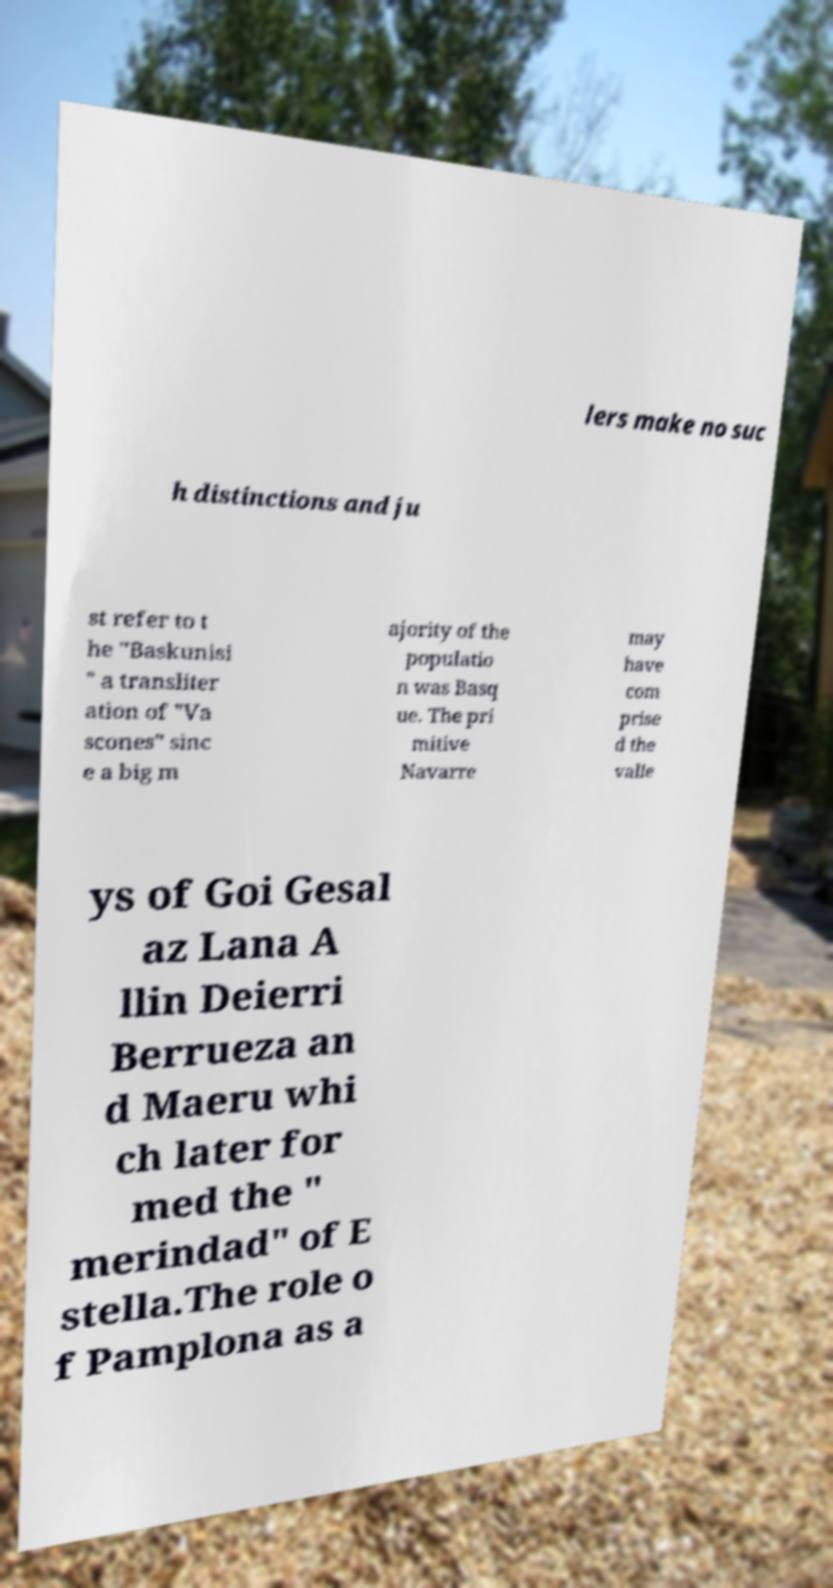Can you accurately transcribe the text from the provided image for me? lers make no suc h distinctions and ju st refer to t he "Baskunisi " a transliter ation of "Va scones" sinc e a big m ajority of the populatio n was Basq ue. The pri mitive Navarre may have com prise d the valle ys of Goi Gesal az Lana A llin Deierri Berrueza an d Maeru whi ch later for med the " merindad" of E stella.The role o f Pamplona as a 